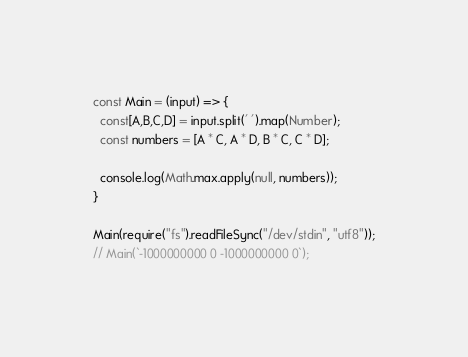<code> <loc_0><loc_0><loc_500><loc_500><_JavaScript_>const Main = (input) => {
  const[A,B,C,D] = input.split(' ').map(Number);
  const numbers = [A * C, A * D, B * C, C * D];
 
  console.log(Math.max.apply(null, numbers));
}

Main(require("fs").readFileSync("/dev/stdin", "utf8"));
// Main(`-1000000000 0 -1000000000 0`);
</code> 